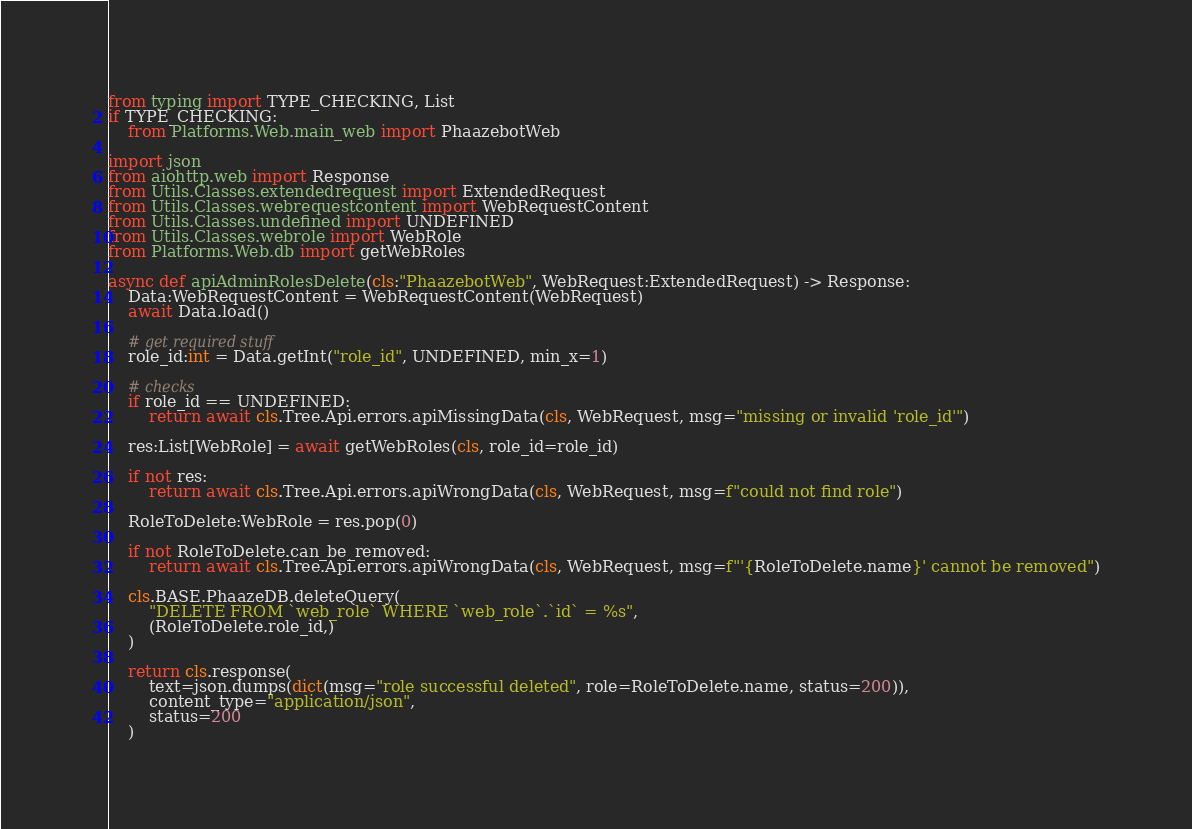Convert code to text. <code><loc_0><loc_0><loc_500><loc_500><_Python_>from typing import TYPE_CHECKING, List
if TYPE_CHECKING:
	from Platforms.Web.main_web import PhaazebotWeb

import json
from aiohttp.web import Response
from Utils.Classes.extendedrequest import ExtendedRequest
from Utils.Classes.webrequestcontent import WebRequestContent
from Utils.Classes.undefined import UNDEFINED
from Utils.Classes.webrole import WebRole
from Platforms.Web.db import getWebRoles

async def apiAdminRolesDelete(cls:"PhaazebotWeb", WebRequest:ExtendedRequest) -> Response:
	Data:WebRequestContent = WebRequestContent(WebRequest)
	await Data.load()

	# get required stuff
	role_id:int = Data.getInt("role_id", UNDEFINED, min_x=1)

	# checks
	if role_id == UNDEFINED:
		return await cls.Tree.Api.errors.apiMissingData(cls, WebRequest, msg="missing or invalid 'role_id'")

	res:List[WebRole] = await getWebRoles(cls, role_id=role_id)

	if not res:
		return await cls.Tree.Api.errors.apiWrongData(cls, WebRequest, msg=f"could not find role")

	RoleToDelete:WebRole = res.pop(0)

	if not RoleToDelete.can_be_removed:
		return await cls.Tree.Api.errors.apiWrongData(cls, WebRequest, msg=f"'{RoleToDelete.name}' cannot be removed")

	cls.BASE.PhaazeDB.deleteQuery(
		"DELETE FROM `web_role` WHERE `web_role`.`id` = %s",
		(RoleToDelete.role_id,)
	)

	return cls.response(
		text=json.dumps(dict(msg="role successful deleted", role=RoleToDelete.name, status=200)),
		content_type="application/json",
		status=200
	)
</code> 